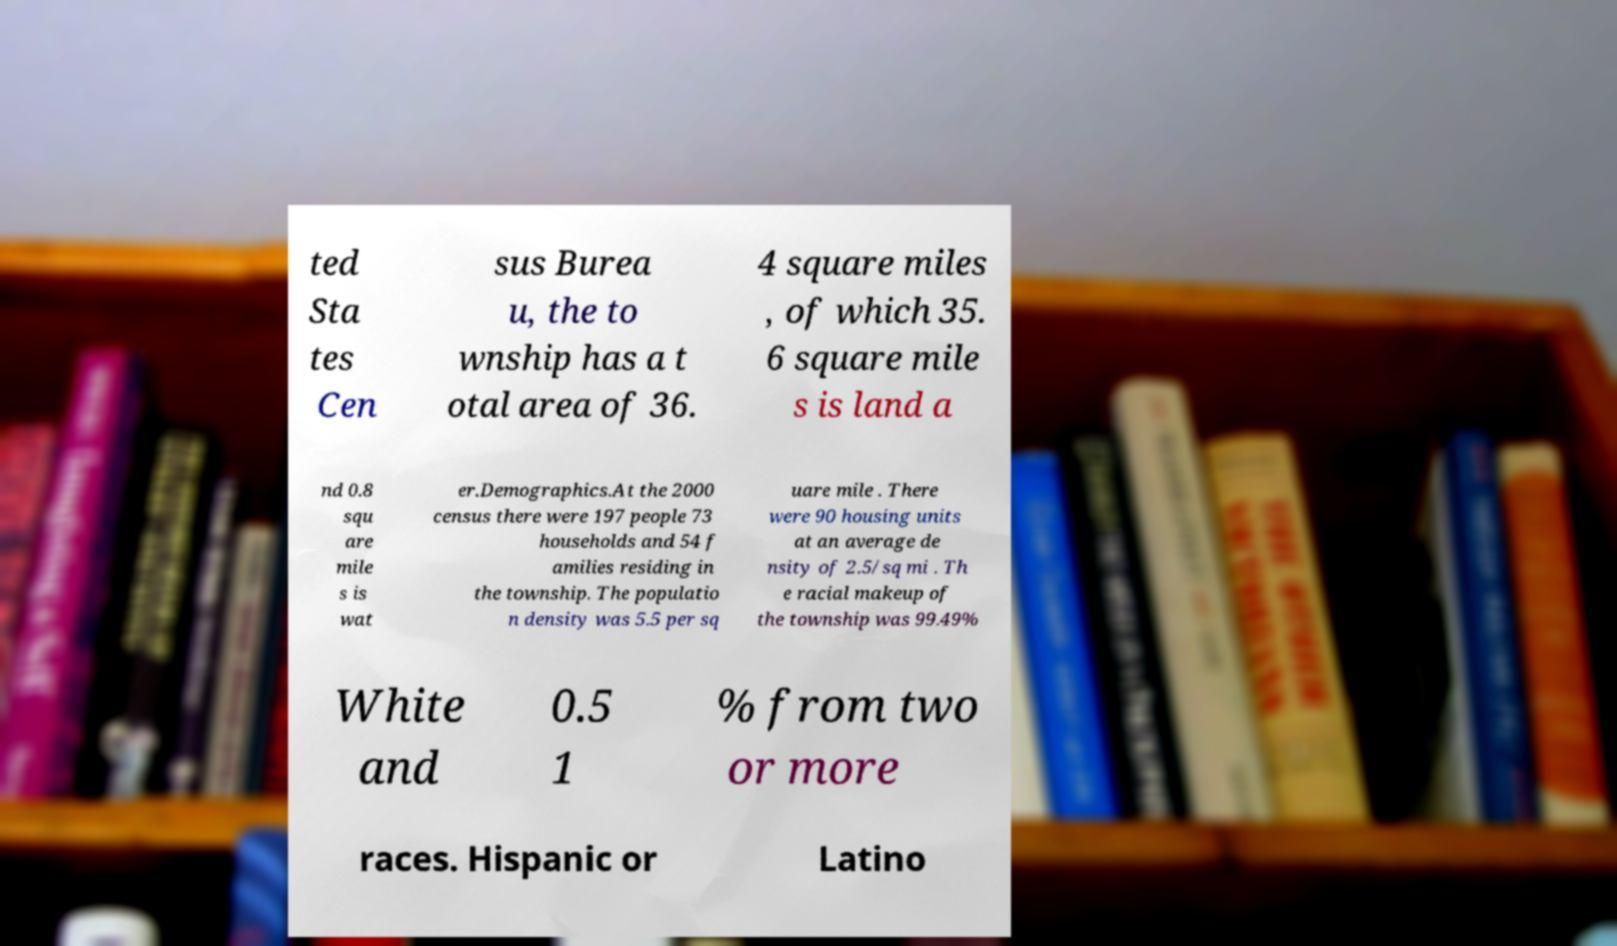Can you read and provide the text displayed in the image?This photo seems to have some interesting text. Can you extract and type it out for me? ted Sta tes Cen sus Burea u, the to wnship has a t otal area of 36. 4 square miles , of which 35. 6 square mile s is land a nd 0.8 squ are mile s is wat er.Demographics.At the 2000 census there were 197 people 73 households and 54 f amilies residing in the township. The populatio n density was 5.5 per sq uare mile . There were 90 housing units at an average de nsity of 2.5/sq mi . Th e racial makeup of the township was 99.49% White and 0.5 1 % from two or more races. Hispanic or Latino 